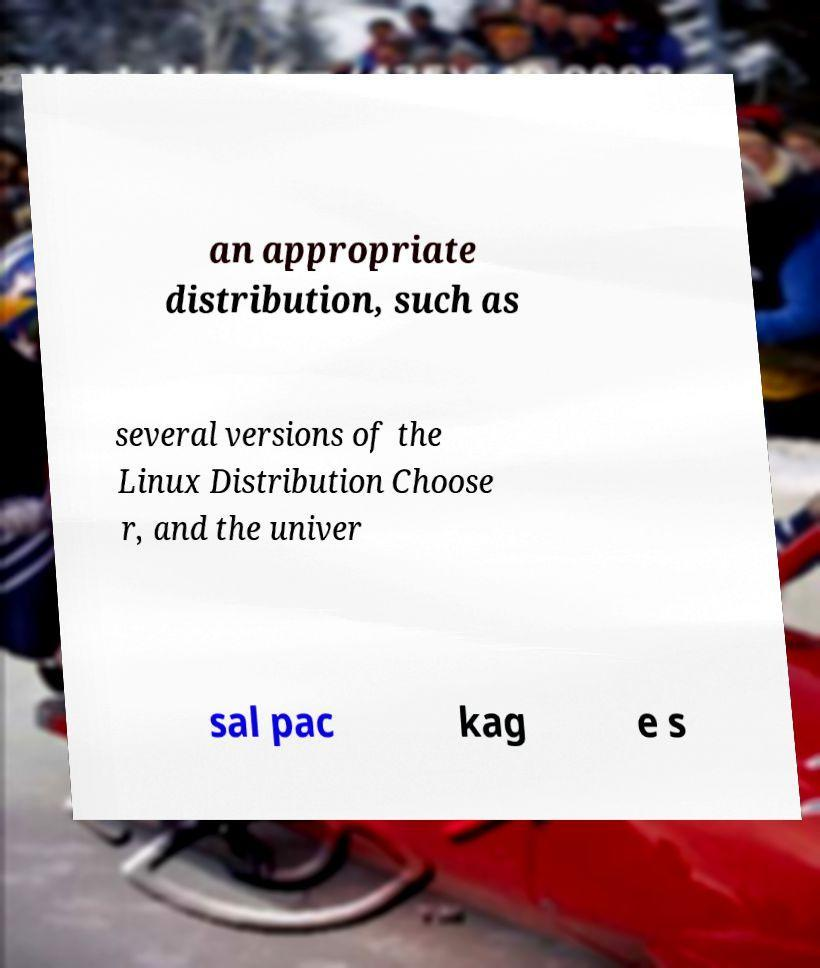Please read and relay the text visible in this image. What does it say? an appropriate distribution, such as several versions of the Linux Distribution Choose r, and the univer sal pac kag e s 